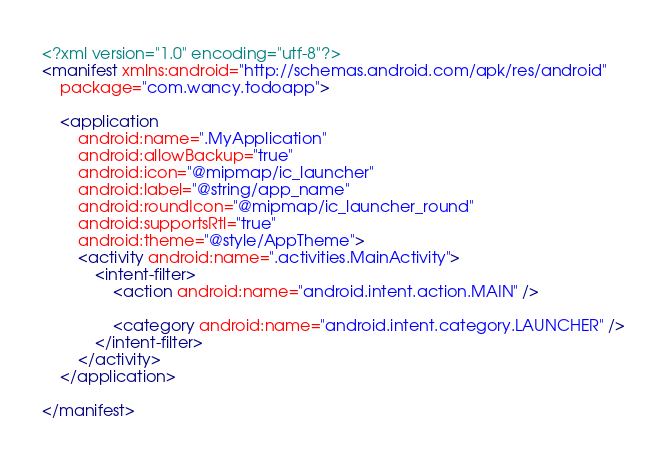<code> <loc_0><loc_0><loc_500><loc_500><_XML_><?xml version="1.0" encoding="utf-8"?>
<manifest xmlns:android="http://schemas.android.com/apk/res/android"
    package="com.wancy.todoapp">

    <application
        android:name=".MyApplication"
        android:allowBackup="true"
        android:icon="@mipmap/ic_launcher"
        android:label="@string/app_name"
        android:roundIcon="@mipmap/ic_launcher_round"
        android:supportsRtl="true"
        android:theme="@style/AppTheme">
        <activity android:name=".activities.MainActivity">
            <intent-filter>
                <action android:name="android.intent.action.MAIN" />

                <category android:name="android.intent.category.LAUNCHER" />
            </intent-filter>
        </activity>
    </application>

</manifest></code> 